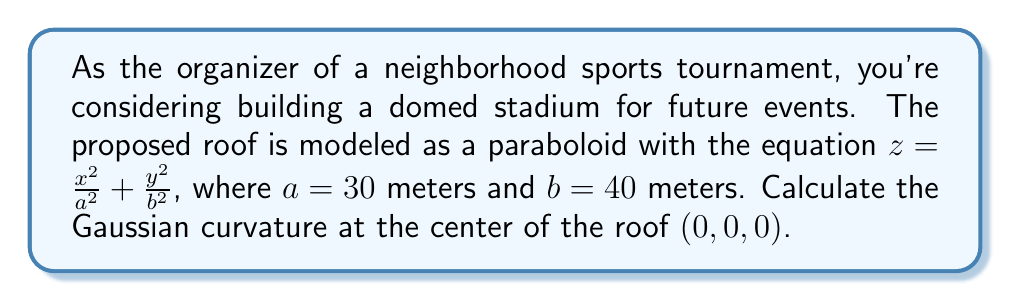Show me your answer to this math problem. To find the Gaussian curvature of the paraboloid roof, we'll follow these steps:

1) The Gaussian curvature K is given by $K = \frac{LN - M^2}{EG - F^2}$, where E, F, G are the coefficients of the first fundamental form, and L, M, N are the coefficients of the second fundamental form.

2) For a surface $z = f(x,y)$, we have:
   $E = 1 + (\frac{\partial f}{\partial x})^2$
   $F = \frac{\partial f}{\partial x}\frac{\partial f}{\partial y}$
   $G = 1 + (\frac{\partial f}{\partial y})^2$
   $L = \frac{\frac{\partial^2 f}{\partial x^2}}{\sqrt{1 + (\frac{\partial f}{\partial x})^2 + (\frac{\partial f}{\partial y})^2}}$
   $M = \frac{\frac{\partial^2 f}{\partial x\partial y}}{\sqrt{1 + (\frac{\partial f}{\partial x})^2 + (\frac{\partial f}{\partial y})^2}}$
   $N = \frac{\frac{\partial^2 f}{\partial y^2}}{\sqrt{1 + (\frac{\partial f}{\partial x})^2 + (\frac{\partial f}{\partial y})^2}}$

3) For our paraboloid $z = \frac{x^2}{a^2} + \frac{y^2}{b^2}$:
   $\frac{\partial f}{\partial x} = \frac{2x}{a^2}$
   $\frac{\partial f}{\partial y} = \frac{2y}{b^2}$
   $\frac{\partial^2 f}{\partial x^2} = \frac{2}{a^2}$
   $\frac{\partial^2 f}{\partial y^2} = \frac{2}{b^2}$
   $\frac{\partial^2 f}{\partial x\partial y} = 0$

4) At the center (0, 0, 0):
   $E = G = 1$, $F = 0$
   $L = \frac{2}{a^2}$, $N = \frac{2}{b^2}$, $M = 0$

5) Substituting into the Gaussian curvature formula:

   $K = \frac{LN - M^2}{EG - F^2} = \frac{\frac{2}{a^2} \cdot \frac{2}{b^2} - 0^2}{1 \cdot 1 - 0^2} = \frac{4}{a^2b^2}$

6) Plugging in $a = 30$ and $b = 40$:

   $K = \frac{4}{30^2 \cdot 40^2} = \frac{1}{9000} \approx 1.11 \times 10^{-4}$ m^(-2)
Answer: $\frac{1}{9000}$ m^(-2) 